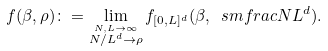<formula> <loc_0><loc_0><loc_500><loc_500>f ( \beta , \rho ) \colon = \lim _ { \stackrel { N , L \to \infty } { N / L ^ { d } \to \rho } } f _ { [ 0 , L ] ^ { d } } ( \beta , { \ s m f r a c { N } { L ^ { d } } } ) .</formula> 